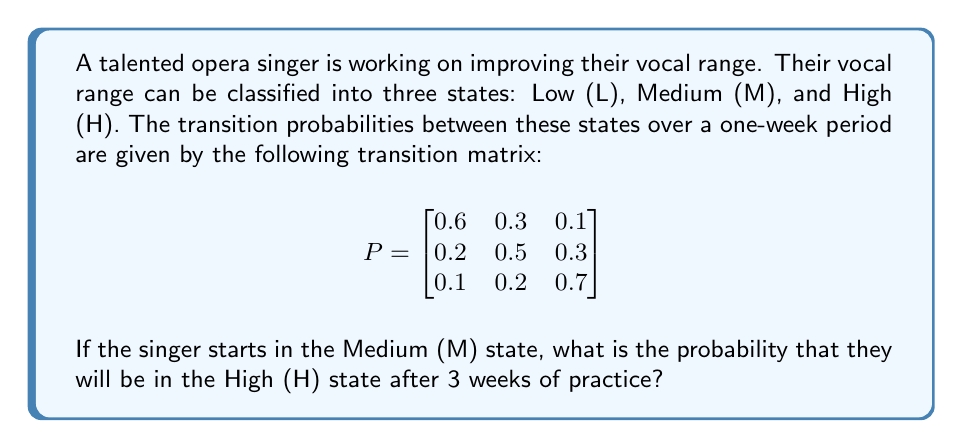What is the answer to this math problem? To solve this problem, we need to use the properties of Markov chains:

1) First, we identify the initial state vector. Since the singer starts in the Medium (M) state, the initial state vector is:

   $$\pi_0 = \begin{bmatrix} 0 & 1 & 0 \end{bmatrix}$$

2) To find the state after 3 weeks, we need to multiply the initial state vector by the transition matrix raised to the power of 3:

   $$\pi_3 = \pi_0 \cdot P^3$$

3) Let's calculate $P^3$:

   $$P^2 = \begin{bmatrix}
   0.42 & 0.33 & 0.25 \\
   0.23 & 0.38 & 0.39 \\
   0.17 & 0.27 & 0.56
   \end{bmatrix}$$

   $$P^3 = \begin{bmatrix}
   0.331 & 0.330 & 0.339 \\
   0.253 & 0.330 & 0.417 \\
   0.211 & 0.294 & 0.495
   \end{bmatrix}$$

4) Now, we multiply $\pi_0$ by $P^3$:

   $$\pi_3 = \begin{bmatrix} 0 & 1 & 0 \end{bmatrix} \cdot \begin{bmatrix}
   0.331 & 0.330 & 0.339 \\
   0.253 & 0.330 & 0.417 \\
   0.211 & 0.294 & 0.495
   \end{bmatrix}$$

   $$\pi_3 = \begin{bmatrix} 0.253 & 0.330 & 0.417 \end{bmatrix}$$

5) The probability of being in the High (H) state after 3 weeks is the third element of $\pi_3$, which is 0.417 or 41.7%.
Answer: 0.417 